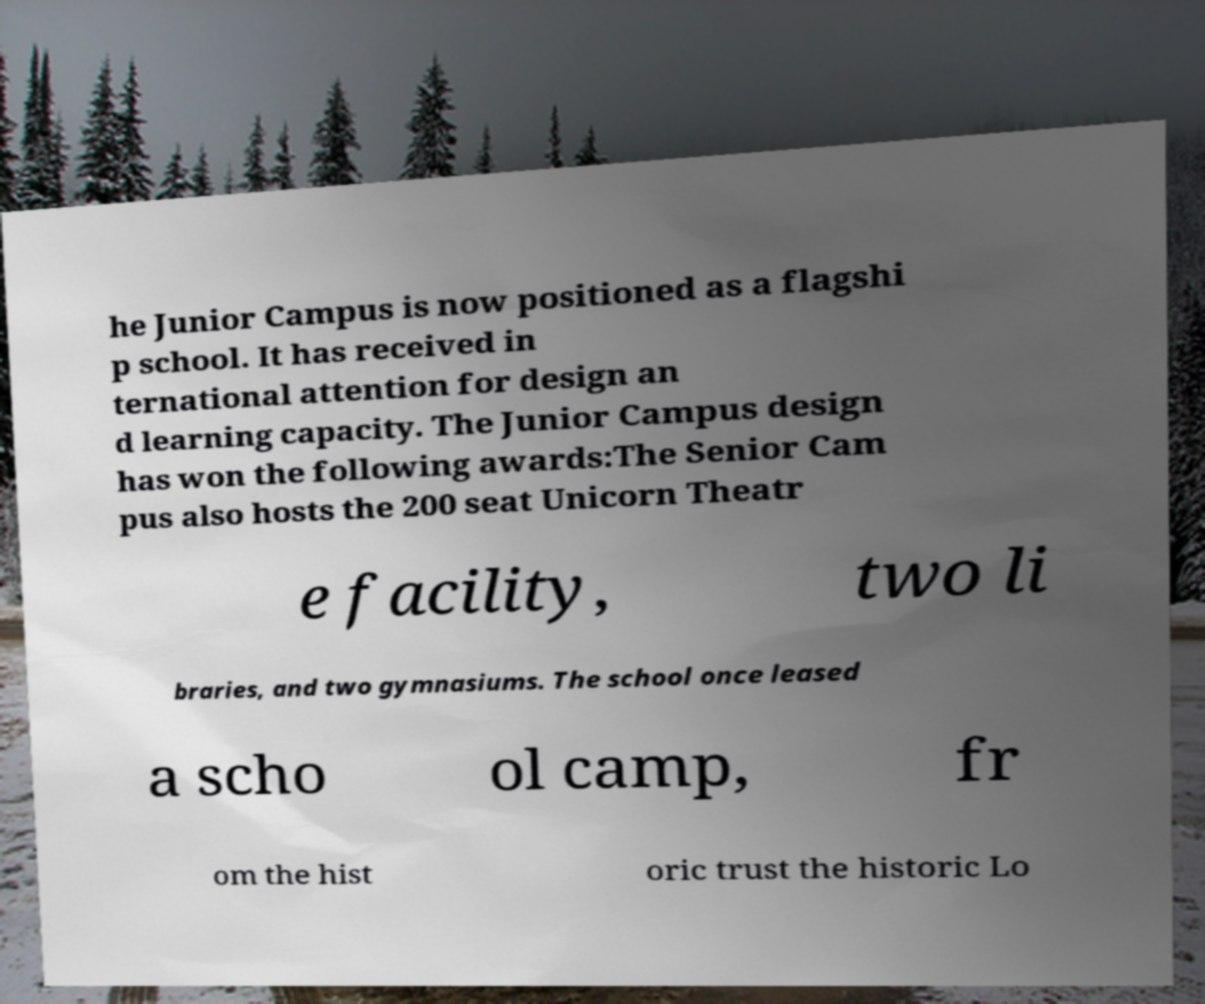Could you assist in decoding the text presented in this image and type it out clearly? he Junior Campus is now positioned as a flagshi p school. It has received in ternational attention for design an d learning capacity. The Junior Campus design has won the following awards:The Senior Cam pus also hosts the 200 seat Unicorn Theatr e facility, two li braries, and two gymnasiums. The school once leased a scho ol camp, fr om the hist oric trust the historic Lo 